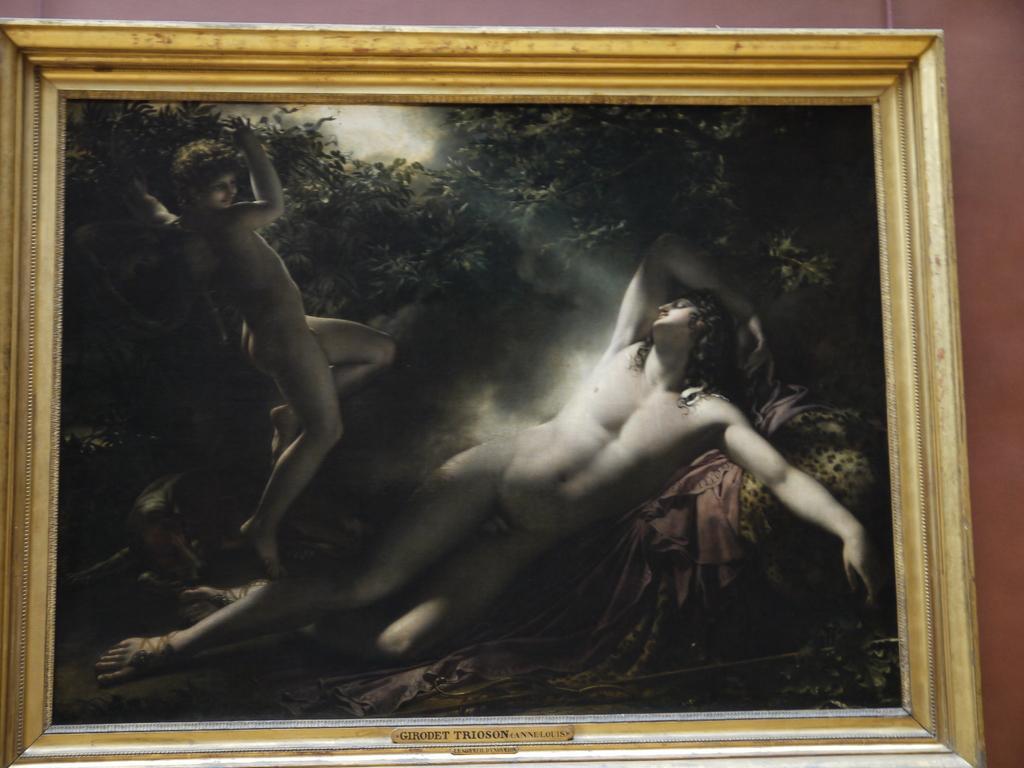In one or two sentences, can you explain what this image depicts? In this image I can see a frame attached to the wall, in the frame I can see two persons and few trees. 